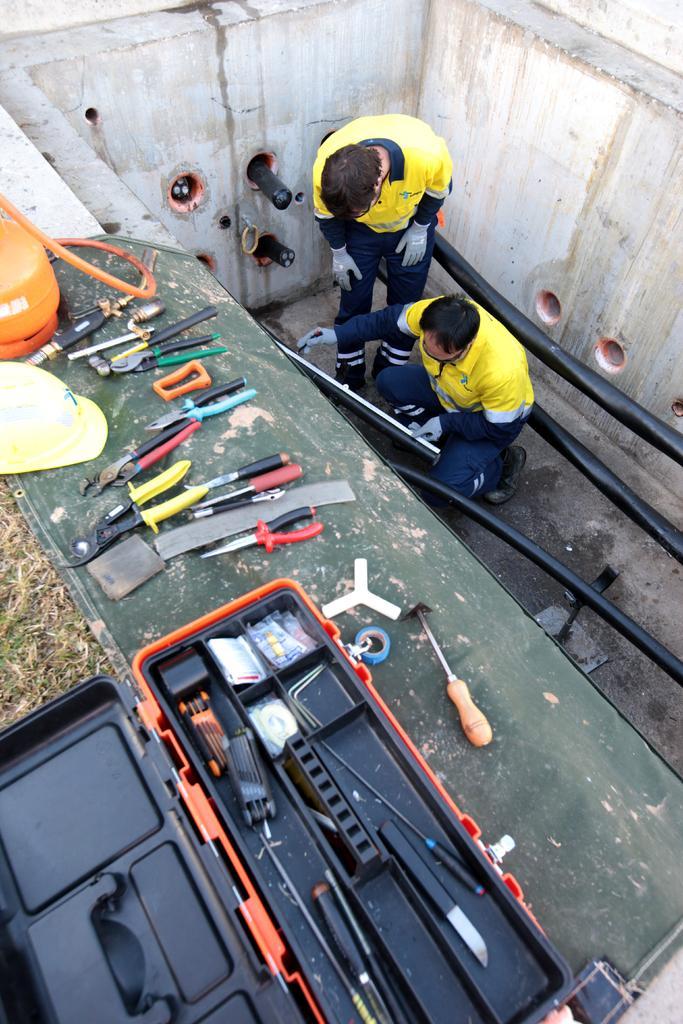Can you describe this image briefly? In this image there are two people, one of them is holding a pipe in one hand and there is like a pen in the other hand, around them there is a wall and pipes, on the wall there are caps and few mechanical objects, there is like a suitcase with some objects in it. 